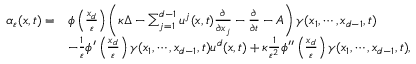<formula> <loc_0><loc_0><loc_500><loc_500>\begin{array} { r l } { \alpha _ { \varepsilon } ( x , t ) = } & { \phi \left ( \frac { x _ { d } } { \varepsilon } \right ) \left ( \kappa \Delta - \sum _ { j = 1 } ^ { d - 1 } u ^ { j } ( x , t ) \frac { \partial } { \partial x _ { j } } - \frac { \partial } { \partial t } - A \right ) \gamma ( x _ { 1 } , \cdots , x _ { d - 1 } , t ) } \\ & { - \frac { 1 } { \varepsilon } \phi ^ { \prime } \left ( \frac { x _ { d } } { \varepsilon } \right ) \gamma ( x _ { 1 } , \cdots , x _ { d - 1 } , t ) u ^ { d } ( x , t ) + \kappa \frac { 1 } { \varepsilon ^ { 2 } } \phi ^ { \prime \prime } \left ( \frac { x _ { d } } { \varepsilon } \right ) \gamma ( x _ { 1 } , \cdots , x _ { d - 1 } , t ) , } \end{array}</formula> 